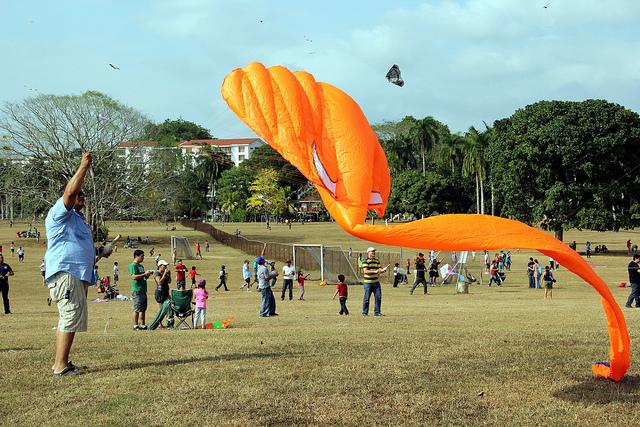Is this shot at night?
Give a very brief answer. No. What color is the kite?
Quick response, please. Orange. Is the man in the front longer than the kite he is flying?
Short answer required. No. 